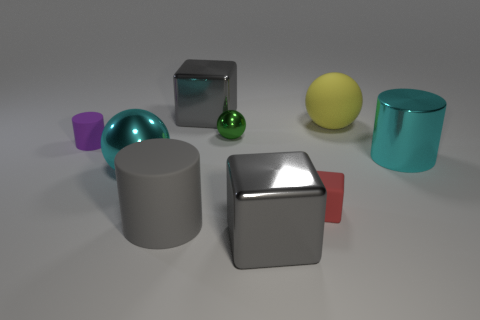There is a big gray metal object behind the purple matte cylinder; what is its shape?
Ensure brevity in your answer.  Cube. What color is the matte ball?
Make the answer very short. Yellow. There is a large cylinder that is made of the same material as the tiny green object; what is its color?
Keep it short and to the point. Cyan. How many large gray objects have the same material as the small cube?
Your response must be concise. 1. There is a large cyan cylinder; how many metallic things are in front of it?
Provide a short and direct response. 2. Do the large cube in front of the green shiny sphere and the large sphere that is left of the yellow object have the same material?
Ensure brevity in your answer.  Yes. Are there more small rubber objects that are in front of the green object than metallic cubes that are on the right side of the big yellow sphere?
Keep it short and to the point. Yes. What is the material of the large ball that is the same color as the metallic cylinder?
Your response must be concise. Metal. Is there any other thing that has the same shape as the large gray matte thing?
Your answer should be compact. Yes. The large thing that is in front of the tiny cube and on the right side of the green metal object is made of what material?
Make the answer very short. Metal. 